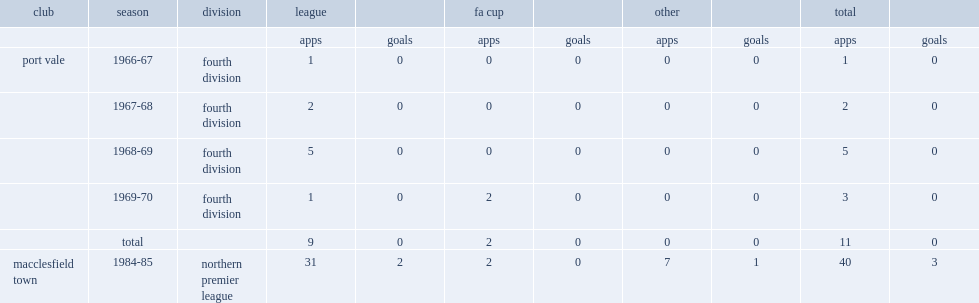Which league did stuart chapman appear in "macclesfield town" from 1984 to 85? Northern premier league. 